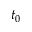<formula> <loc_0><loc_0><loc_500><loc_500>t _ { 0 }</formula> 